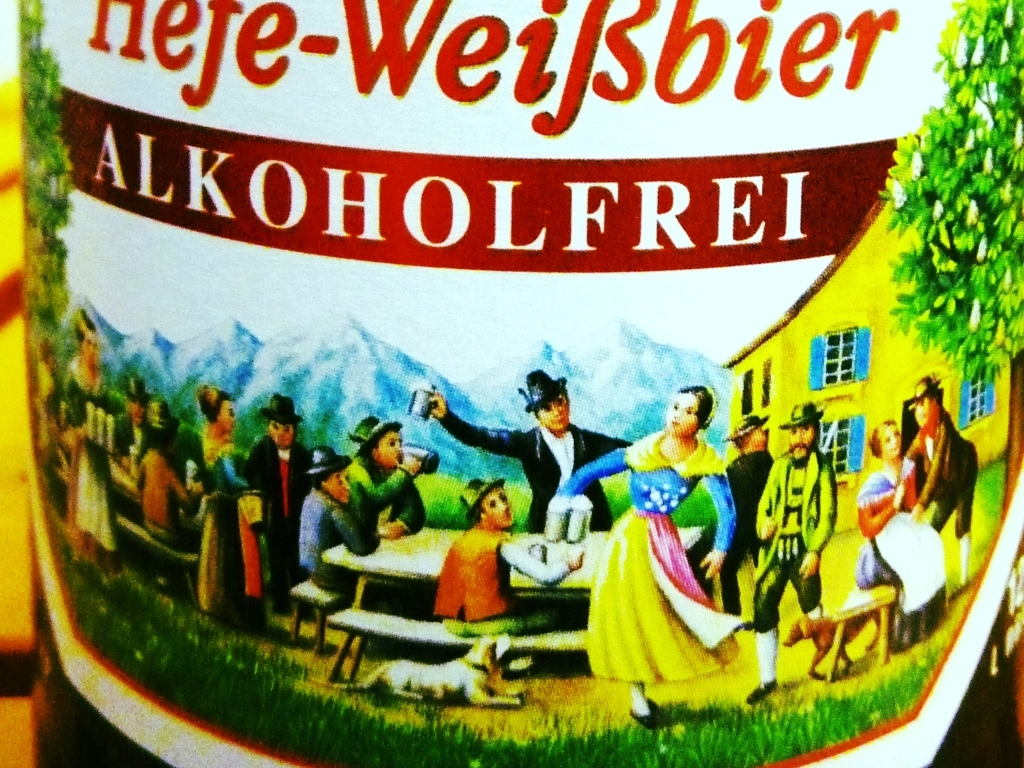What is the style of the image, and what does it represent? The image depicts a traditional beer label in a classic folk art style. It represents a jovial scene typical of a German beer garden or a festive gathering. The artwork is colorful, presenting people in historical costumes enjoying themselves, which reflects the cultural heritage associated with enjoying this type of beverage. The mountain landscape in the background suggests an alpine setting. 